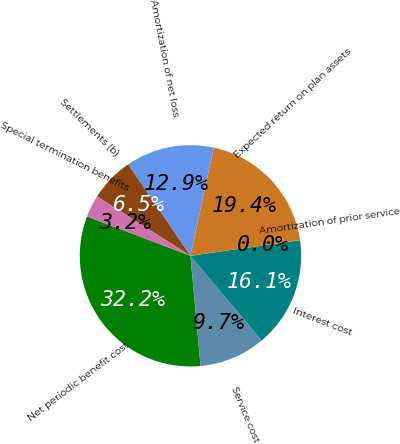Convert chart. <chart><loc_0><loc_0><loc_500><loc_500><pie_chart><fcel>Net periodic benefit cost<fcel>Service cost<fcel>Interest cost<fcel>Amortization of prior service<fcel>Expected return on plan assets<fcel>Amortization of net loss<fcel>Settlements (b)<fcel>Special termination benefits<nl><fcel>32.23%<fcel>9.68%<fcel>16.12%<fcel>0.02%<fcel>19.35%<fcel>12.9%<fcel>6.46%<fcel>3.24%<nl></chart> 